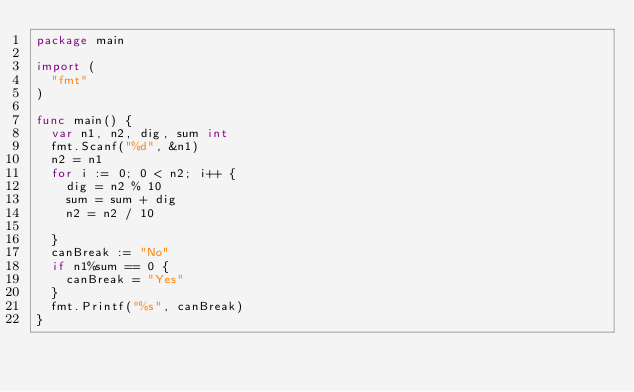Convert code to text. <code><loc_0><loc_0><loc_500><loc_500><_Go_>package main

import (
	"fmt"
)

func main() {
	var n1, n2, dig, sum int
	fmt.Scanf("%d", &n1)
	n2 = n1
	for i := 0; 0 < n2; i++ {
		dig = n2 % 10
		sum = sum + dig
		n2 = n2 / 10

	}
	canBreak := "No"
	if n1%sum == 0 {
		canBreak = "Yes"
	}
	fmt.Printf("%s", canBreak)
}</code> 